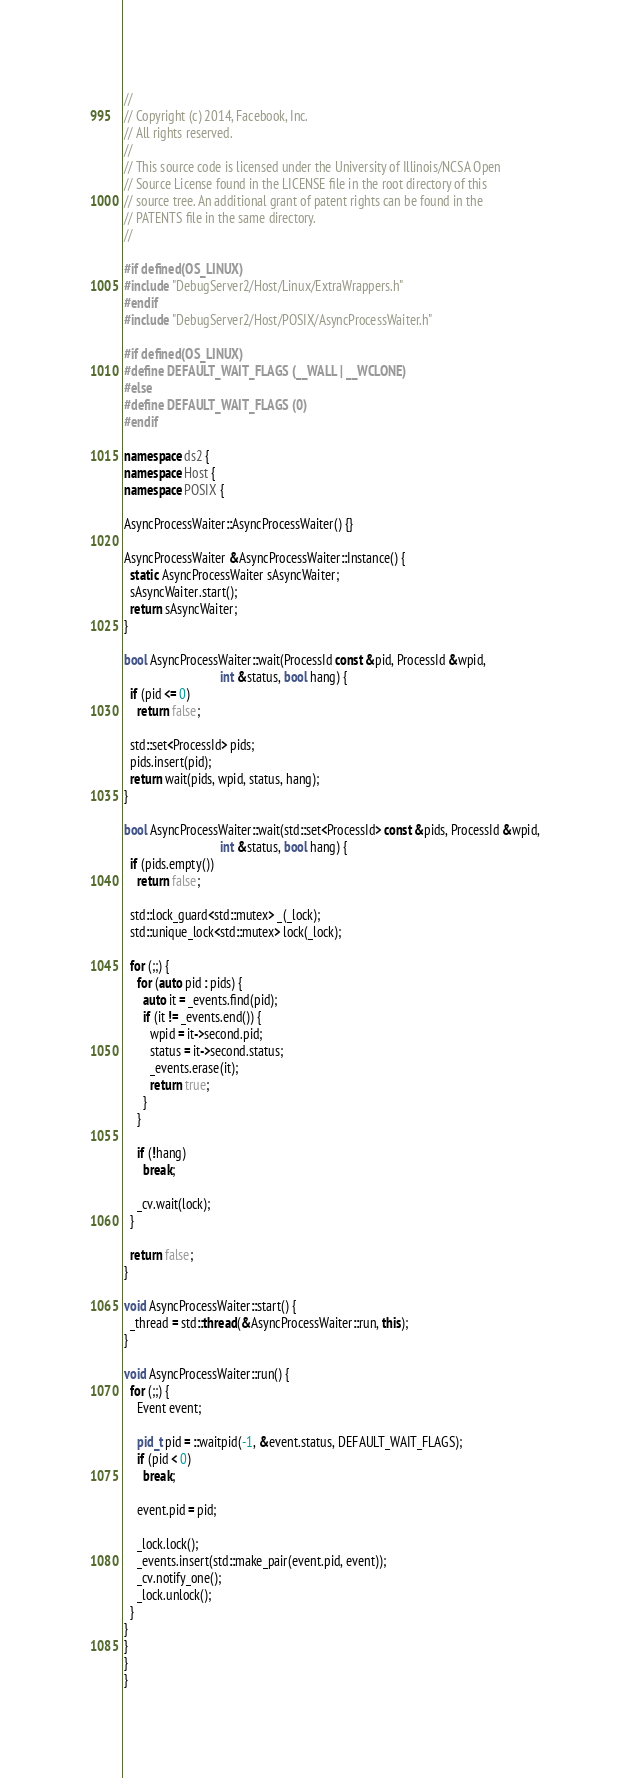<code> <loc_0><loc_0><loc_500><loc_500><_C++_>//
// Copyright (c) 2014, Facebook, Inc.
// All rights reserved.
//
// This source code is licensed under the University of Illinois/NCSA Open
// Source License found in the LICENSE file in the root directory of this
// source tree. An additional grant of patent rights can be found in the
// PATENTS file in the same directory.
//

#if defined(OS_LINUX)
#include "DebugServer2/Host/Linux/ExtraWrappers.h"
#endif
#include "DebugServer2/Host/POSIX/AsyncProcessWaiter.h"

#if defined(OS_LINUX)
#define DEFAULT_WAIT_FLAGS (__WALL | __WCLONE)
#else
#define DEFAULT_WAIT_FLAGS (0)
#endif

namespace ds2 {
namespace Host {
namespace POSIX {

AsyncProcessWaiter::AsyncProcessWaiter() {}

AsyncProcessWaiter &AsyncProcessWaiter::Instance() {
  static AsyncProcessWaiter sAsyncWaiter;
  sAsyncWaiter.start();
  return sAsyncWaiter;
}

bool AsyncProcessWaiter::wait(ProcessId const &pid, ProcessId &wpid,
                              int &status, bool hang) {
  if (pid <= 0)
    return false;

  std::set<ProcessId> pids;
  pids.insert(pid);
  return wait(pids, wpid, status, hang);
}

bool AsyncProcessWaiter::wait(std::set<ProcessId> const &pids, ProcessId &wpid,
                              int &status, bool hang) {
  if (pids.empty())
    return false;

  std::lock_guard<std::mutex> _(_lock);
  std::unique_lock<std::mutex> lock(_lock);

  for (;;) {
    for (auto pid : pids) {
      auto it = _events.find(pid);
      if (it != _events.end()) {
        wpid = it->second.pid;
        status = it->second.status;
        _events.erase(it);
        return true;
      }
    }

    if (!hang)
      break;

    _cv.wait(lock);
  }

  return false;
}

void AsyncProcessWaiter::start() {
  _thread = std::thread(&AsyncProcessWaiter::run, this);
}

void AsyncProcessWaiter::run() {
  for (;;) {
    Event event;

    pid_t pid = ::waitpid(-1, &event.status, DEFAULT_WAIT_FLAGS);
    if (pid < 0)
      break;

    event.pid = pid;

    _lock.lock();
    _events.insert(std::make_pair(event.pid, event));
    _cv.notify_one();
    _lock.unlock();
  }
}
}
}
}
</code> 